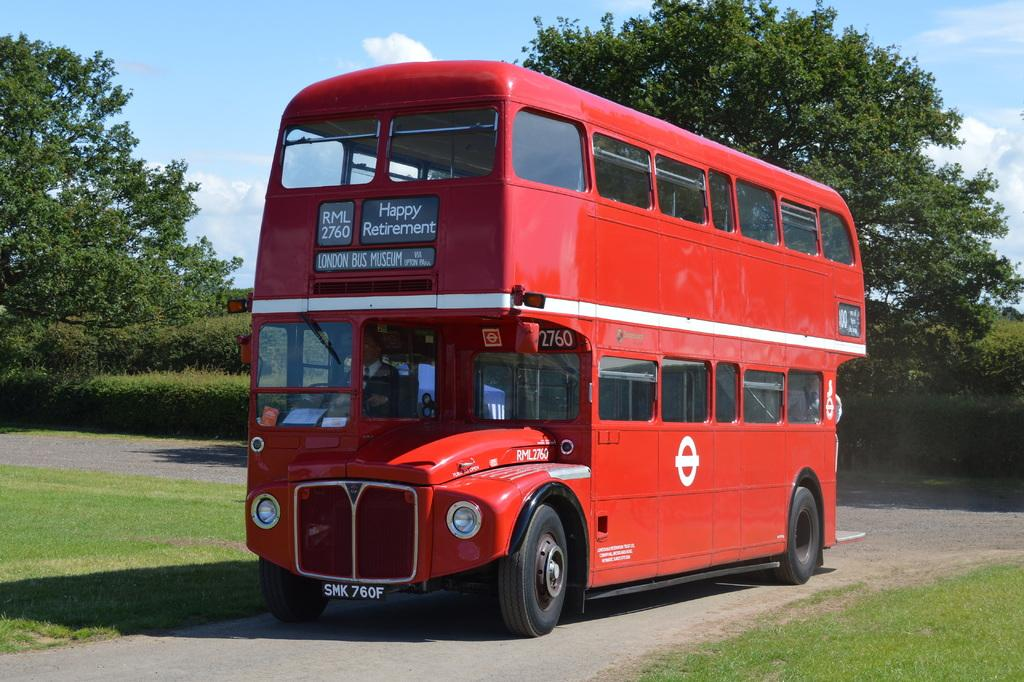<image>
Create a compact narrative representing the image presented. a red double decker bus from The London Bus Museum reading Happy Retirement 